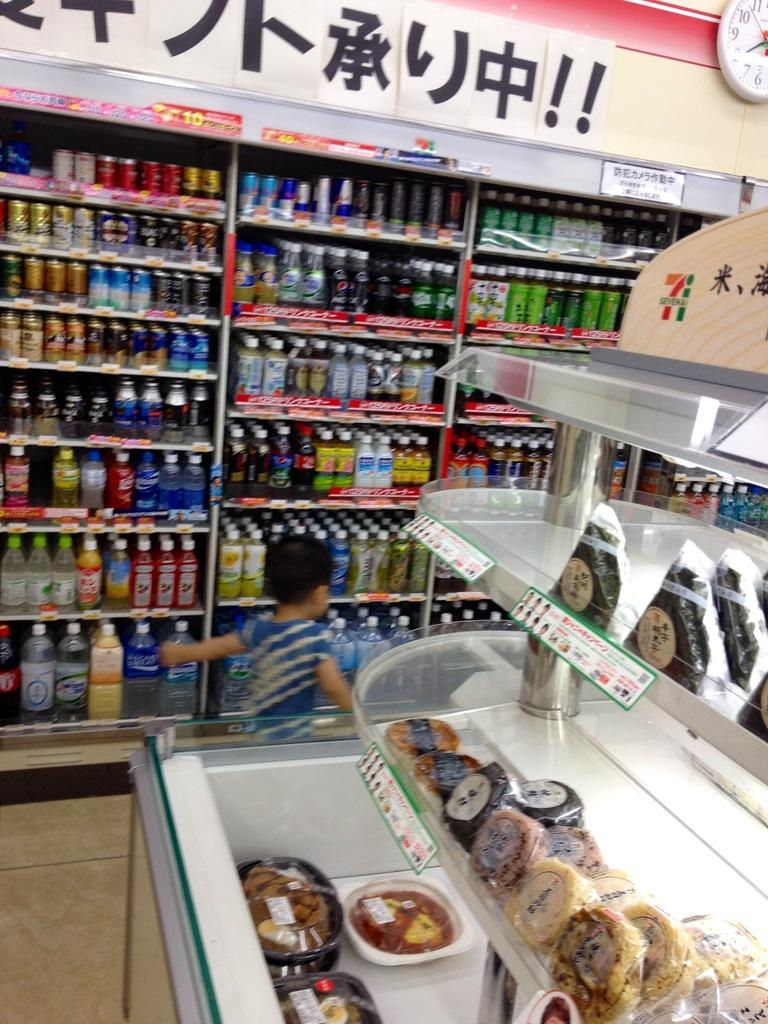<image>
Summarize the visual content of the image. Shelves full of drinks behind a display of foodstuffs with a label of 7i. 